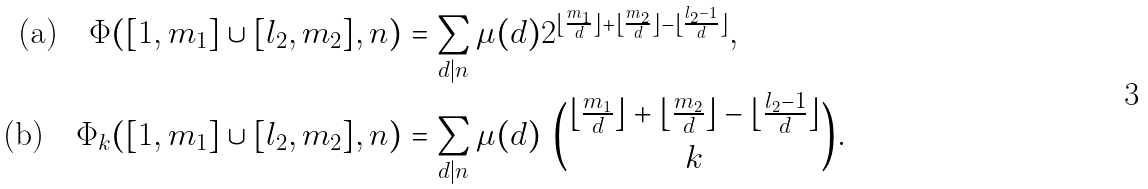<formula> <loc_0><loc_0><loc_500><loc_500>\text {(a)\quad } \Phi ( [ 1 , m _ { 1 } ] \cup [ l _ { 2 } , m _ { 2 } ] , n ) & = \sum _ { d | n } \mu ( d ) 2 ^ { \lfloor \frac { m _ { 1 } } { d } \rfloor + \lfloor \frac { m _ { 2 } } { d } \rfloor - \lfloor \frac { l _ { 2 } - 1 } { d } \rfloor } , \\ \text {(b)\quad } \Phi _ { k } ( [ 1 , m _ { 1 } ] \cup [ l _ { 2 } , m _ { 2 } ] , n ) & = \sum _ { d | n } \mu ( d ) \ \binom { \lfloor \frac { m _ { 1 } } { d } \rfloor + \lfloor \frac { m _ { 2 } } { d } \rfloor - \lfloor \frac { l _ { 2 } - 1 } { d } \rfloor } { k } .</formula> 